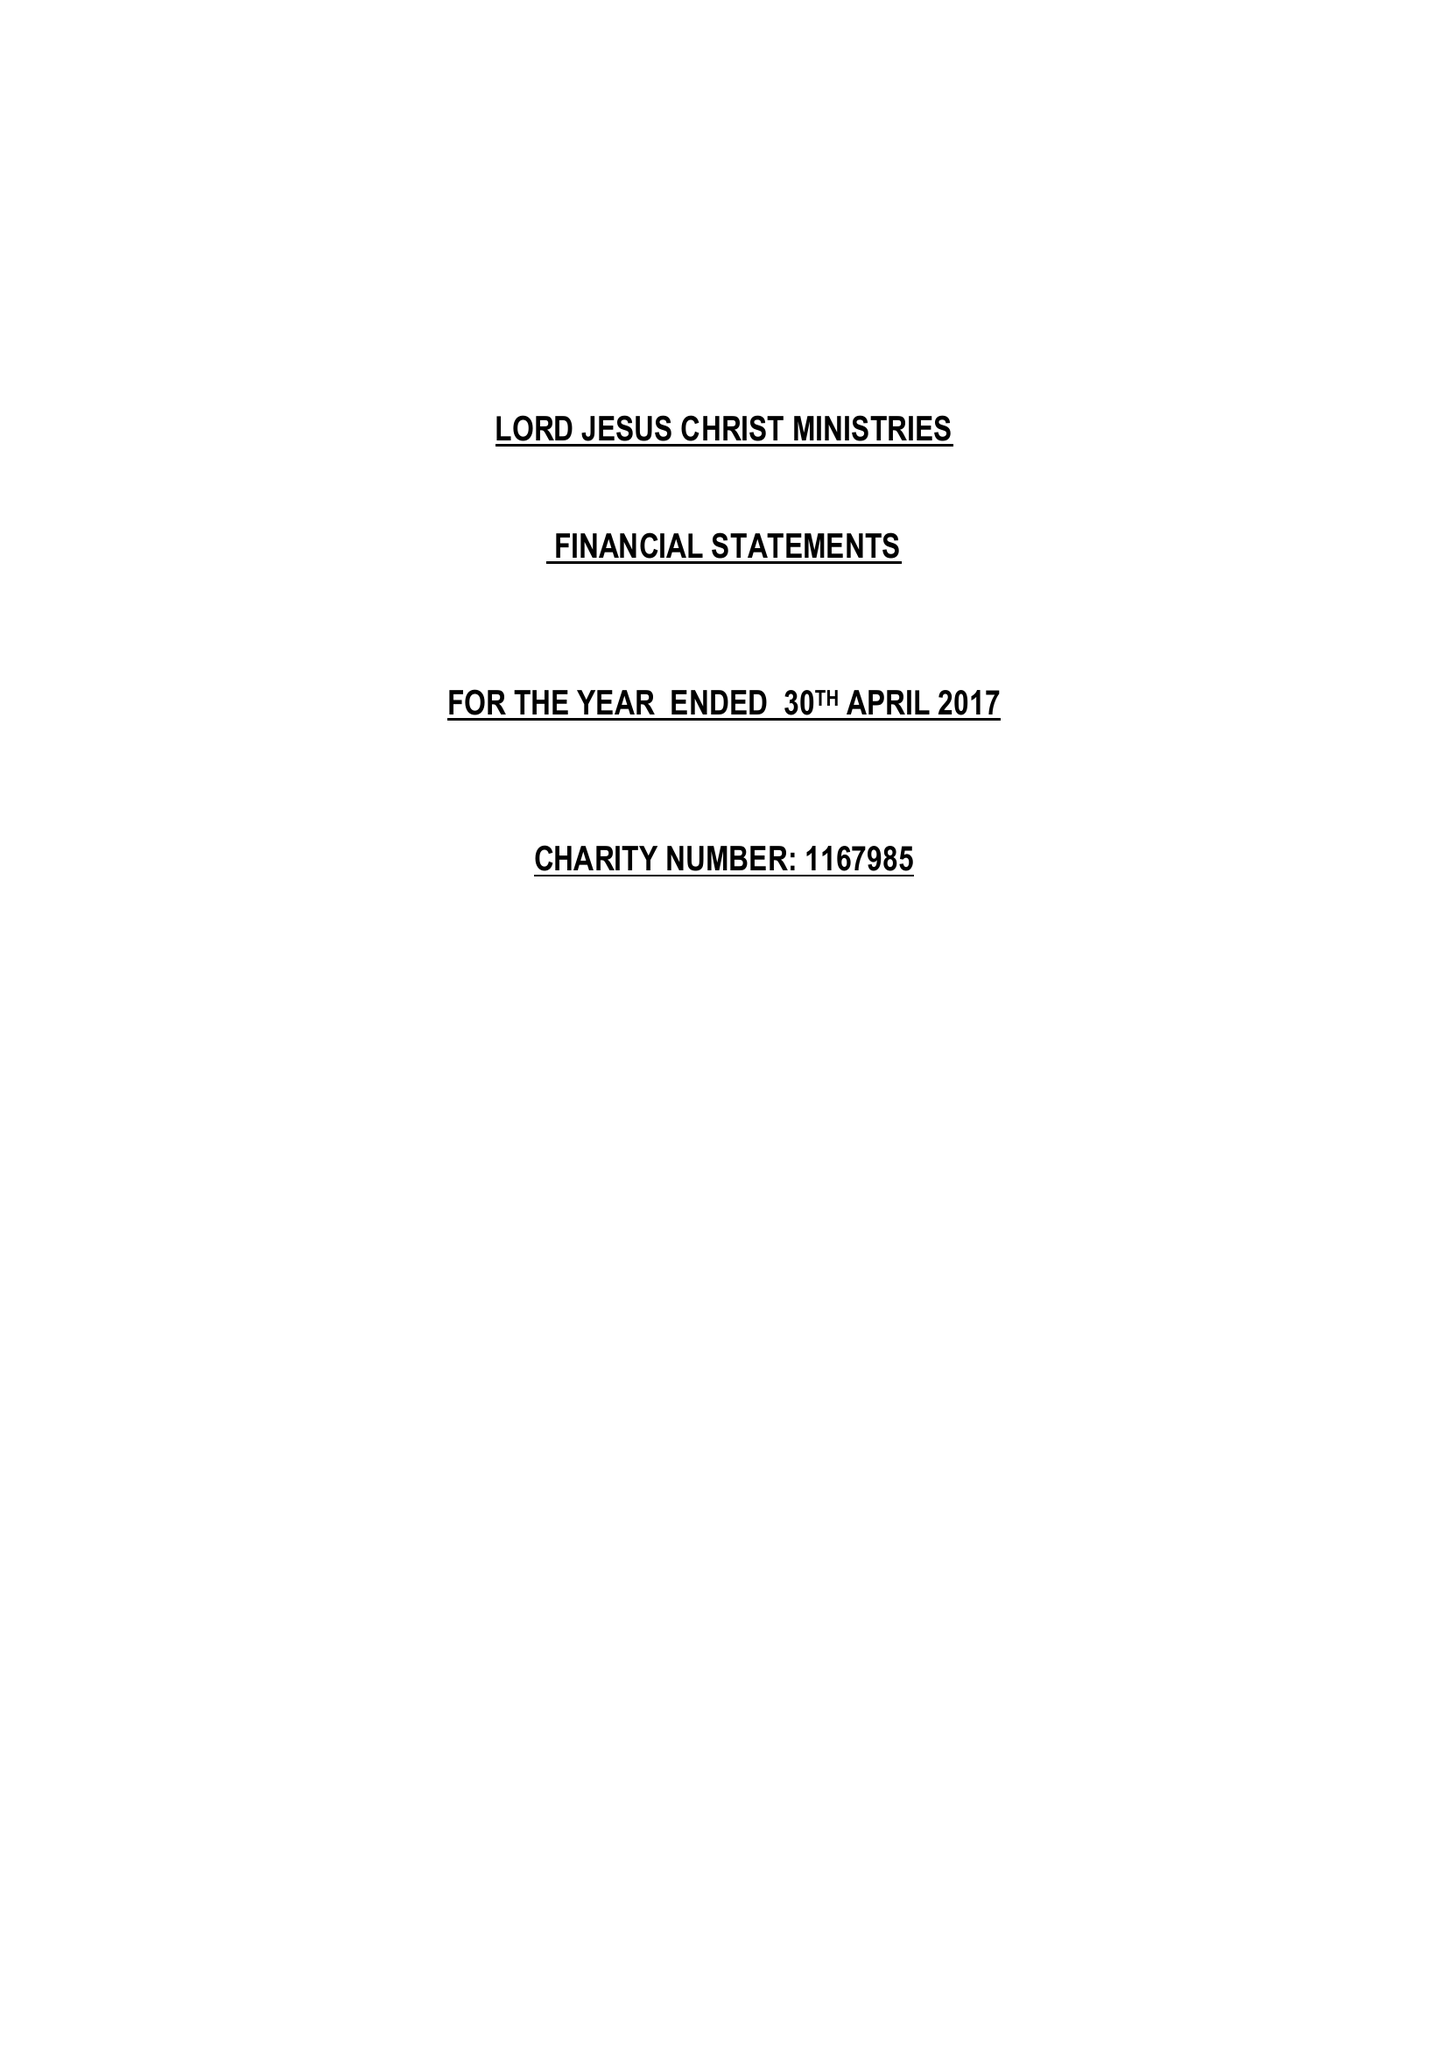What is the value for the address__postcode?
Answer the question using a single word or phrase. MK2 3ER 